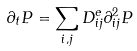Convert formula to latex. <formula><loc_0><loc_0><loc_500><loc_500>\partial _ { t } P = \sum _ { i , j } D _ { i j } ^ { e } \partial ^ { 2 } _ { i j } P</formula> 